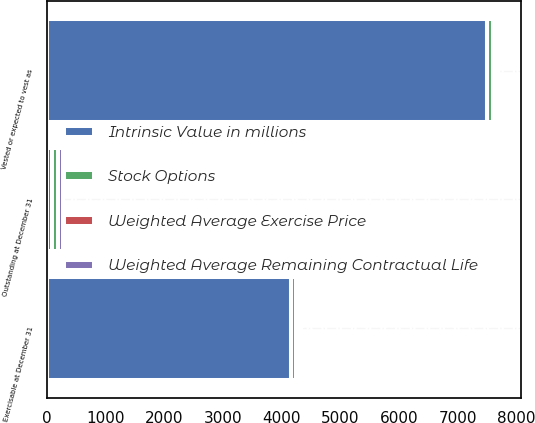Convert chart to OTSL. <chart><loc_0><loc_0><loc_500><loc_500><stacked_bar_chart><ecel><fcel>Outstanding at December 31<fcel>Vested or expected to vest as<fcel>Exercisable at December 31<nl><fcel>Intrinsic Value in millions<fcel>82<fcel>7503<fcel>4159<nl><fcel>Stock Options<fcel>100.29<fcel>99.76<fcel>87.57<nl><fcel>Weighted Average Exercise Price<fcel>6.6<fcel>6.5<fcel>5<nl><fcel>Weighted Average Remaining Contractual Life<fcel>82<fcel>81.9<fcel>80.9<nl></chart> 